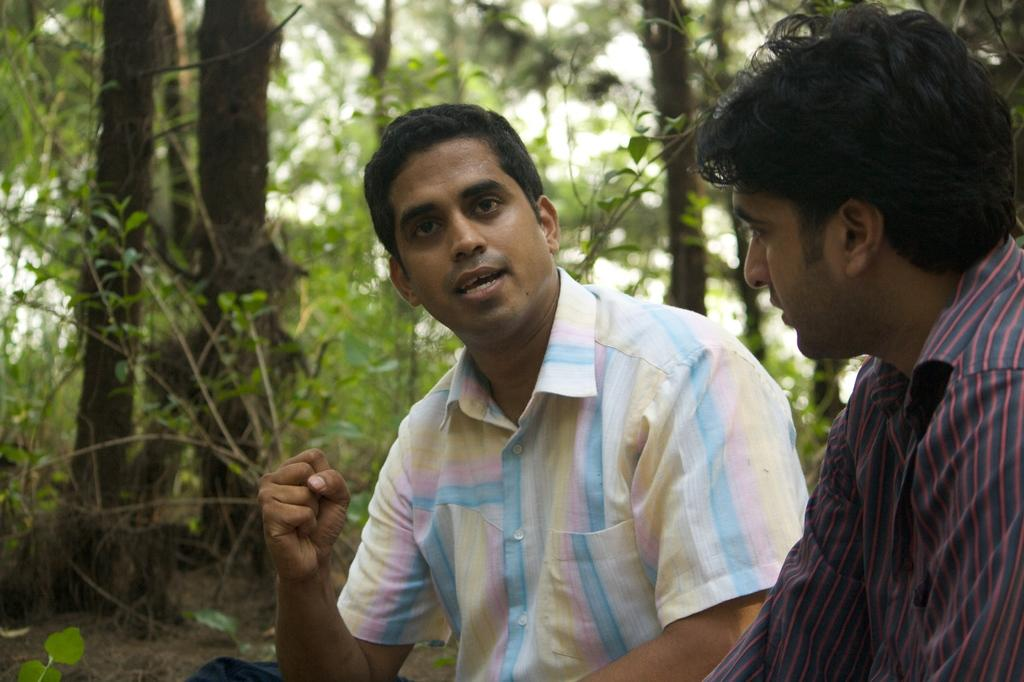How many people are in the image? There are two men in the image. What type of natural feature can be seen in the image? There is a group of trees in the image. What is visible on the trees in the image? The bark of the trees is visible in the image. What part of the natural environment is visible in the image? The sky is visible in the image. What type of cannon can be seen in the image? There is no cannon present in the image. Which actor is performing in the image? There is no actor or performance depicted in the image. 